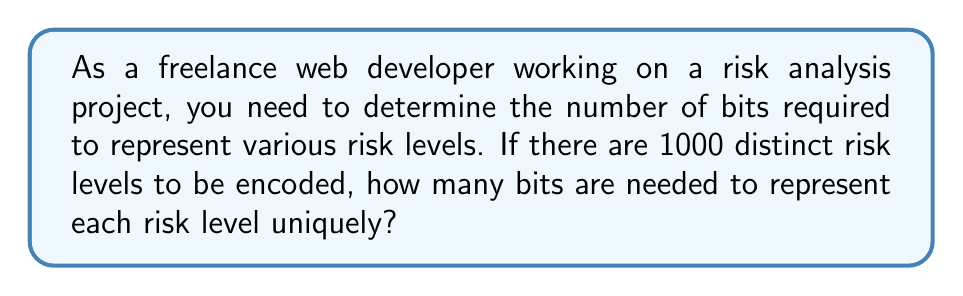Solve this math problem. To solve this problem, we'll use logarithmic properties. Here's the step-by-step solution:

1) The number of distinct values that can be represented with $n$ bits is $2^n$.

2) We need to find the smallest $n$ such that $2^n \geq 1000$.

3) Taking the logarithm base 2 of both sides:

   $\log_2(2^n) \geq \log_2(1000)$

4) Using the logarithm property $\log_a(a^x) = x$, we get:

   $n \geq \log_2(1000)$

5) Calculate $\log_2(1000)$:
   
   $\log_2(1000) \approx 9.965784284662087$

6) Since $n$ must be an integer and we need to cover all 1000 values, we round up to the next whole number:

   $n = \lceil 9.965784284662087 \rceil = 10$

Therefore, we need 10 bits to represent 1000 distinct risk levels.
Answer: 10 bits 